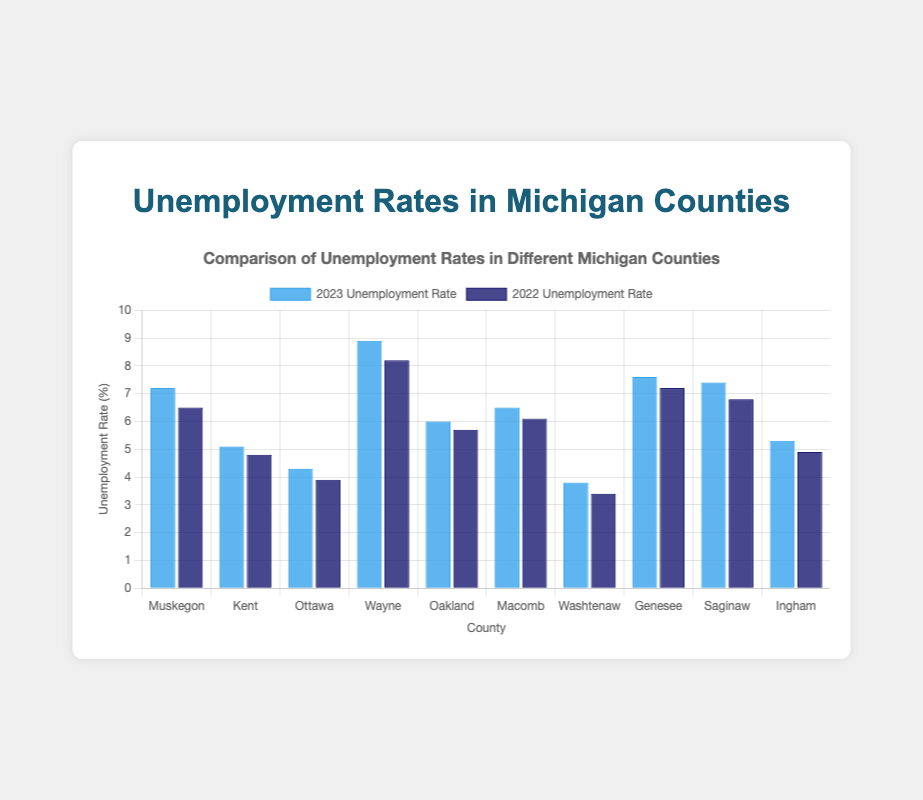Which county had the highest unemployment rate in 2023? By looking at the bars for 2023, the tallest one represents the county with the highest unemployment rate. The tall bar for Wayne County shows the highest rate.
Answer: Wayne Which county had the lowest unemployment rate in 2023? By identifying the shortest bar in the 2023 group, the smallest bar belongs to Washtenaw County.
Answer: Washtenaw Which counties had an increase in unemployment rates from 2022 to 2023? Compare the heights of the two bars (2022 and 2023) for each county. If the 2023 bar is taller, it indicates an increase. The relevant counties are Muskegon, Wayne, Oakland, Macomb, Washtenaw, Genesee, Saginaw, and Ingham.
Answer: Muskegon, Wayne, Oakland, Macomb, Washtenaw, Genesee, Saginaw, Ingham In which county was the increase in unemployment rate from 2022 to 2023 the greatest? Calculate the difference between 2023 and 2022 rates for each county and identify the one with the largest difference. Wayne County shows the greatest increase (8.9 - 8.2 = 0.7).
Answer: Wayne Compare the unemployment rates of Kent and Ottawa counties in 2023. Which one was higher? Look at the heights of the 2023 bars for Kent and Ottawa counties. The bar for Kent is taller than for Ottawa, indicating a higher rate.
Answer: Kent What is the average unemployment rate across all counties in 2023? Sum up all the unemployment rates for 2023 and divide by the number of counties: (7.2+5.1+4.3+8.9+6.0+6.5+3.8+7.6+7.4+5.3) / 10 = 6.21.
Answer: 6.21 Did any counties have the same unemployment rate in both 2022 and 2023? By looking at the pairs of bars for each county, none of the counties have bars of equal height for both years.
Answer: No Which county had the smallest increase in unemployment rate from 2022 to 2023? Calculate the difference between 2023 and 2022 rates for each county and find the smallest positive difference. Ottawa County has the smallest increase (4.3 - 3.9 = 0.4).
Answer: Ottawa What is the average increase in unemployment rates from 2022 to 2023 across all counties? Calculate the difference for each county and then find the average: (7.2-6.5 + 5.1-4.8 + 4.3-3.9 + 8.9-8.2 + 6.0-5.7 + 6.5-6.1 + 3.8-3.4 + 7.6-7.2 + 7.4-6.8 + 5.3-4.9) / 10 = (0.7 + 0.3 + 0.4 + 0.7 + 0.3 + 0.4 + 0.4 + 0.4 + 0.6 + 0.4) / 10 = 0.46.
Answer: 0.46 How did Muskegon's unemployment rate change from 2022 to 2023? Muskegon's 2022 rate was 6.5, and the 2023 rate was 7.2. The change is 7.2 - 6.5 = 0.7, indicating an increase.
Answer: Increased by 0.7 